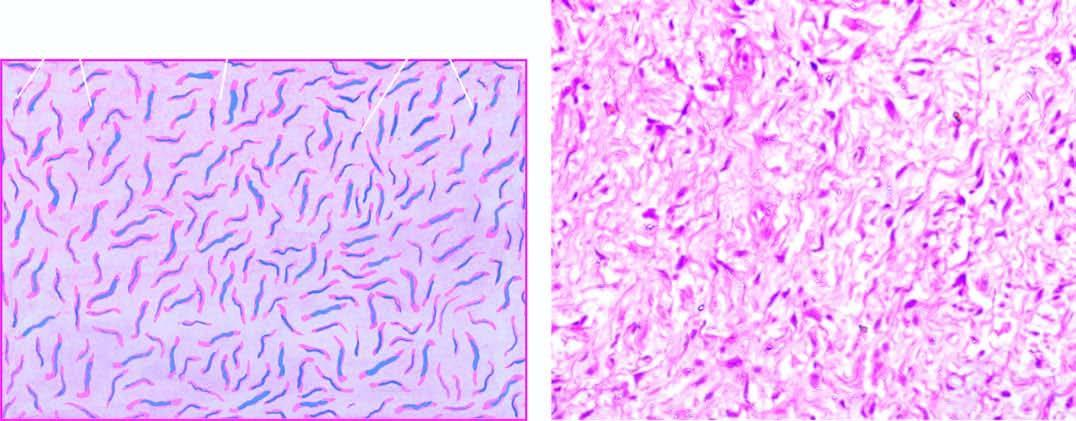what does neurofibrom show?
Answer the question using a single word or phrase. Interlacing bundles of spindle-shaped cells separated by mucoid matrix 